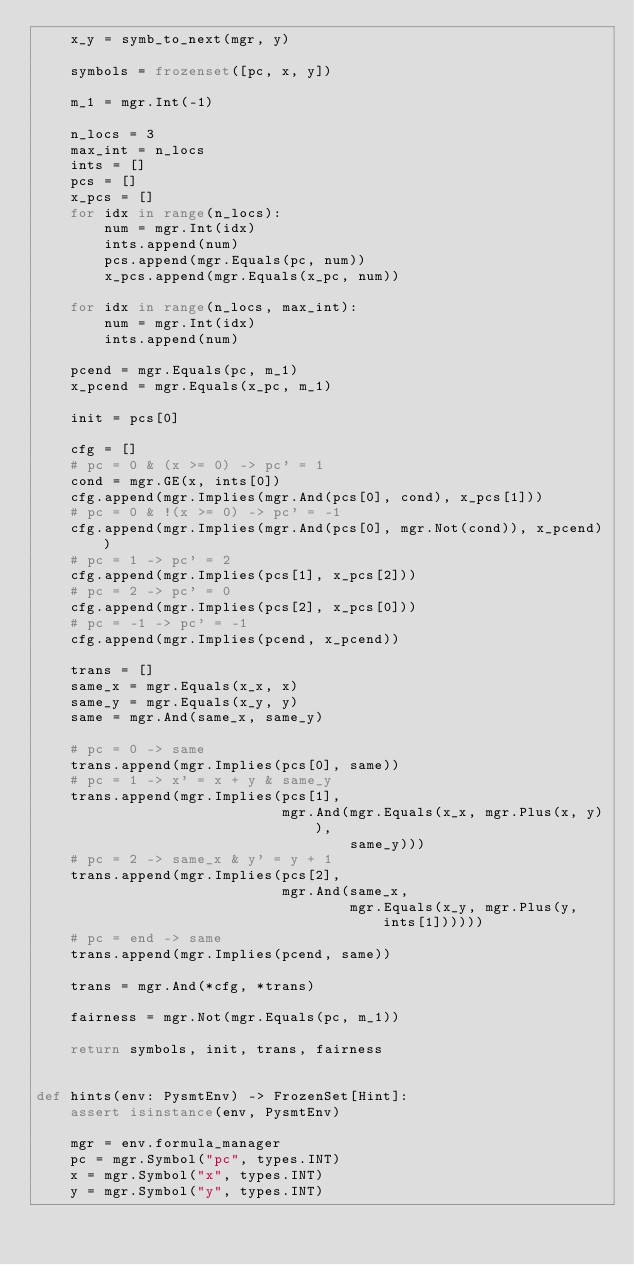<code> <loc_0><loc_0><loc_500><loc_500><_Python_>    x_y = symb_to_next(mgr, y)

    symbols = frozenset([pc, x, y])

    m_1 = mgr.Int(-1)

    n_locs = 3
    max_int = n_locs
    ints = []
    pcs = []
    x_pcs = []
    for idx in range(n_locs):
        num = mgr.Int(idx)
        ints.append(num)
        pcs.append(mgr.Equals(pc, num))
        x_pcs.append(mgr.Equals(x_pc, num))

    for idx in range(n_locs, max_int):
        num = mgr.Int(idx)
        ints.append(num)

    pcend = mgr.Equals(pc, m_1)
    x_pcend = mgr.Equals(x_pc, m_1)

    init = pcs[0]

    cfg = []
    # pc = 0 & (x >= 0) -> pc' = 1
    cond = mgr.GE(x, ints[0])
    cfg.append(mgr.Implies(mgr.And(pcs[0], cond), x_pcs[1]))
    # pc = 0 & !(x >= 0) -> pc' = -1
    cfg.append(mgr.Implies(mgr.And(pcs[0], mgr.Not(cond)), x_pcend))
    # pc = 1 -> pc' = 2
    cfg.append(mgr.Implies(pcs[1], x_pcs[2]))
    # pc = 2 -> pc' = 0
    cfg.append(mgr.Implies(pcs[2], x_pcs[0]))
    # pc = -1 -> pc' = -1
    cfg.append(mgr.Implies(pcend, x_pcend))

    trans = []
    same_x = mgr.Equals(x_x, x)
    same_y = mgr.Equals(x_y, y)
    same = mgr.And(same_x, same_y)

    # pc = 0 -> same
    trans.append(mgr.Implies(pcs[0], same))
    # pc = 1 -> x' = x + y & same_y
    trans.append(mgr.Implies(pcs[1],
                             mgr.And(mgr.Equals(x_x, mgr.Plus(x, y)),
                                     same_y)))
    # pc = 2 -> same_x & y' = y + 1
    trans.append(mgr.Implies(pcs[2],
                             mgr.And(same_x,
                                     mgr.Equals(x_y, mgr.Plus(y, ints[1])))))
    # pc = end -> same
    trans.append(mgr.Implies(pcend, same))

    trans = mgr.And(*cfg, *trans)

    fairness = mgr.Not(mgr.Equals(pc, m_1))

    return symbols, init, trans, fairness


def hints(env: PysmtEnv) -> FrozenSet[Hint]:
    assert isinstance(env, PysmtEnv)

    mgr = env.formula_manager
    pc = mgr.Symbol("pc", types.INT)
    x = mgr.Symbol("x", types.INT)
    y = mgr.Symbol("y", types.INT)</code> 